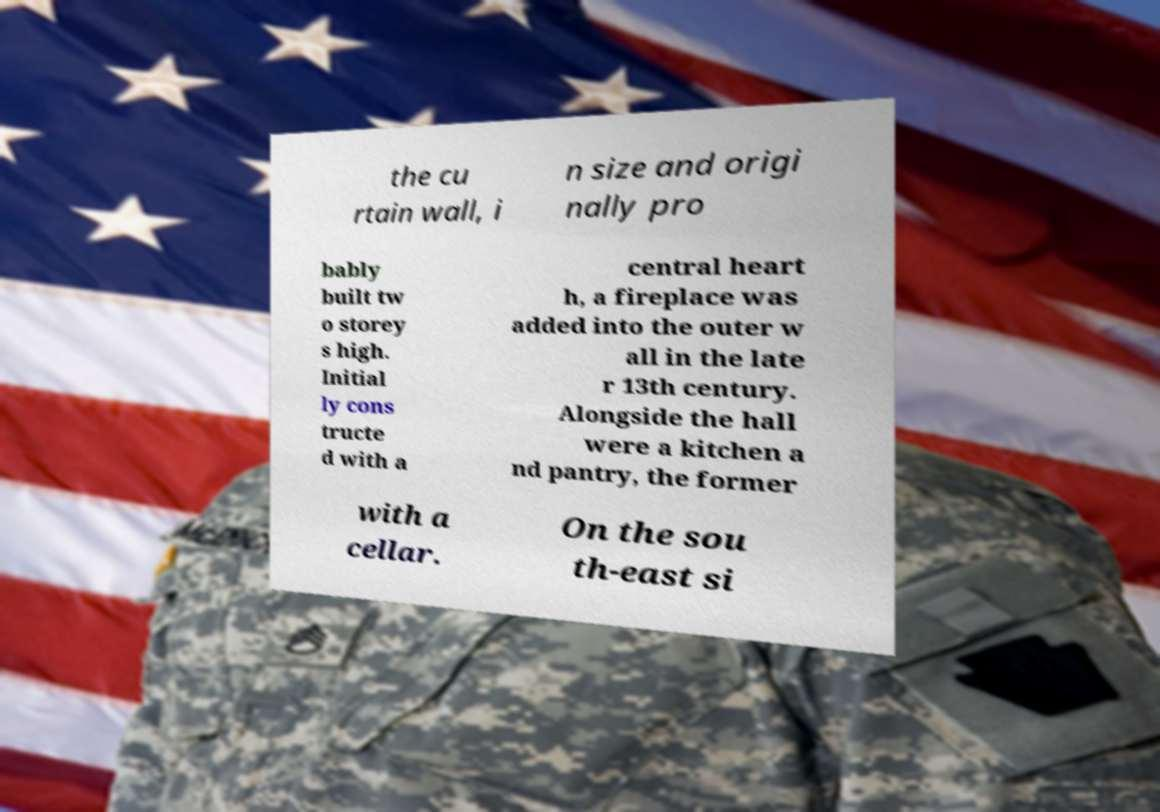Please identify and transcribe the text found in this image. the cu rtain wall, i n size and origi nally pro bably built tw o storey s high. Initial ly cons tructe d with a central heart h, a fireplace was added into the outer w all in the late r 13th century. Alongside the hall were a kitchen a nd pantry, the former with a cellar. On the sou th-east si 